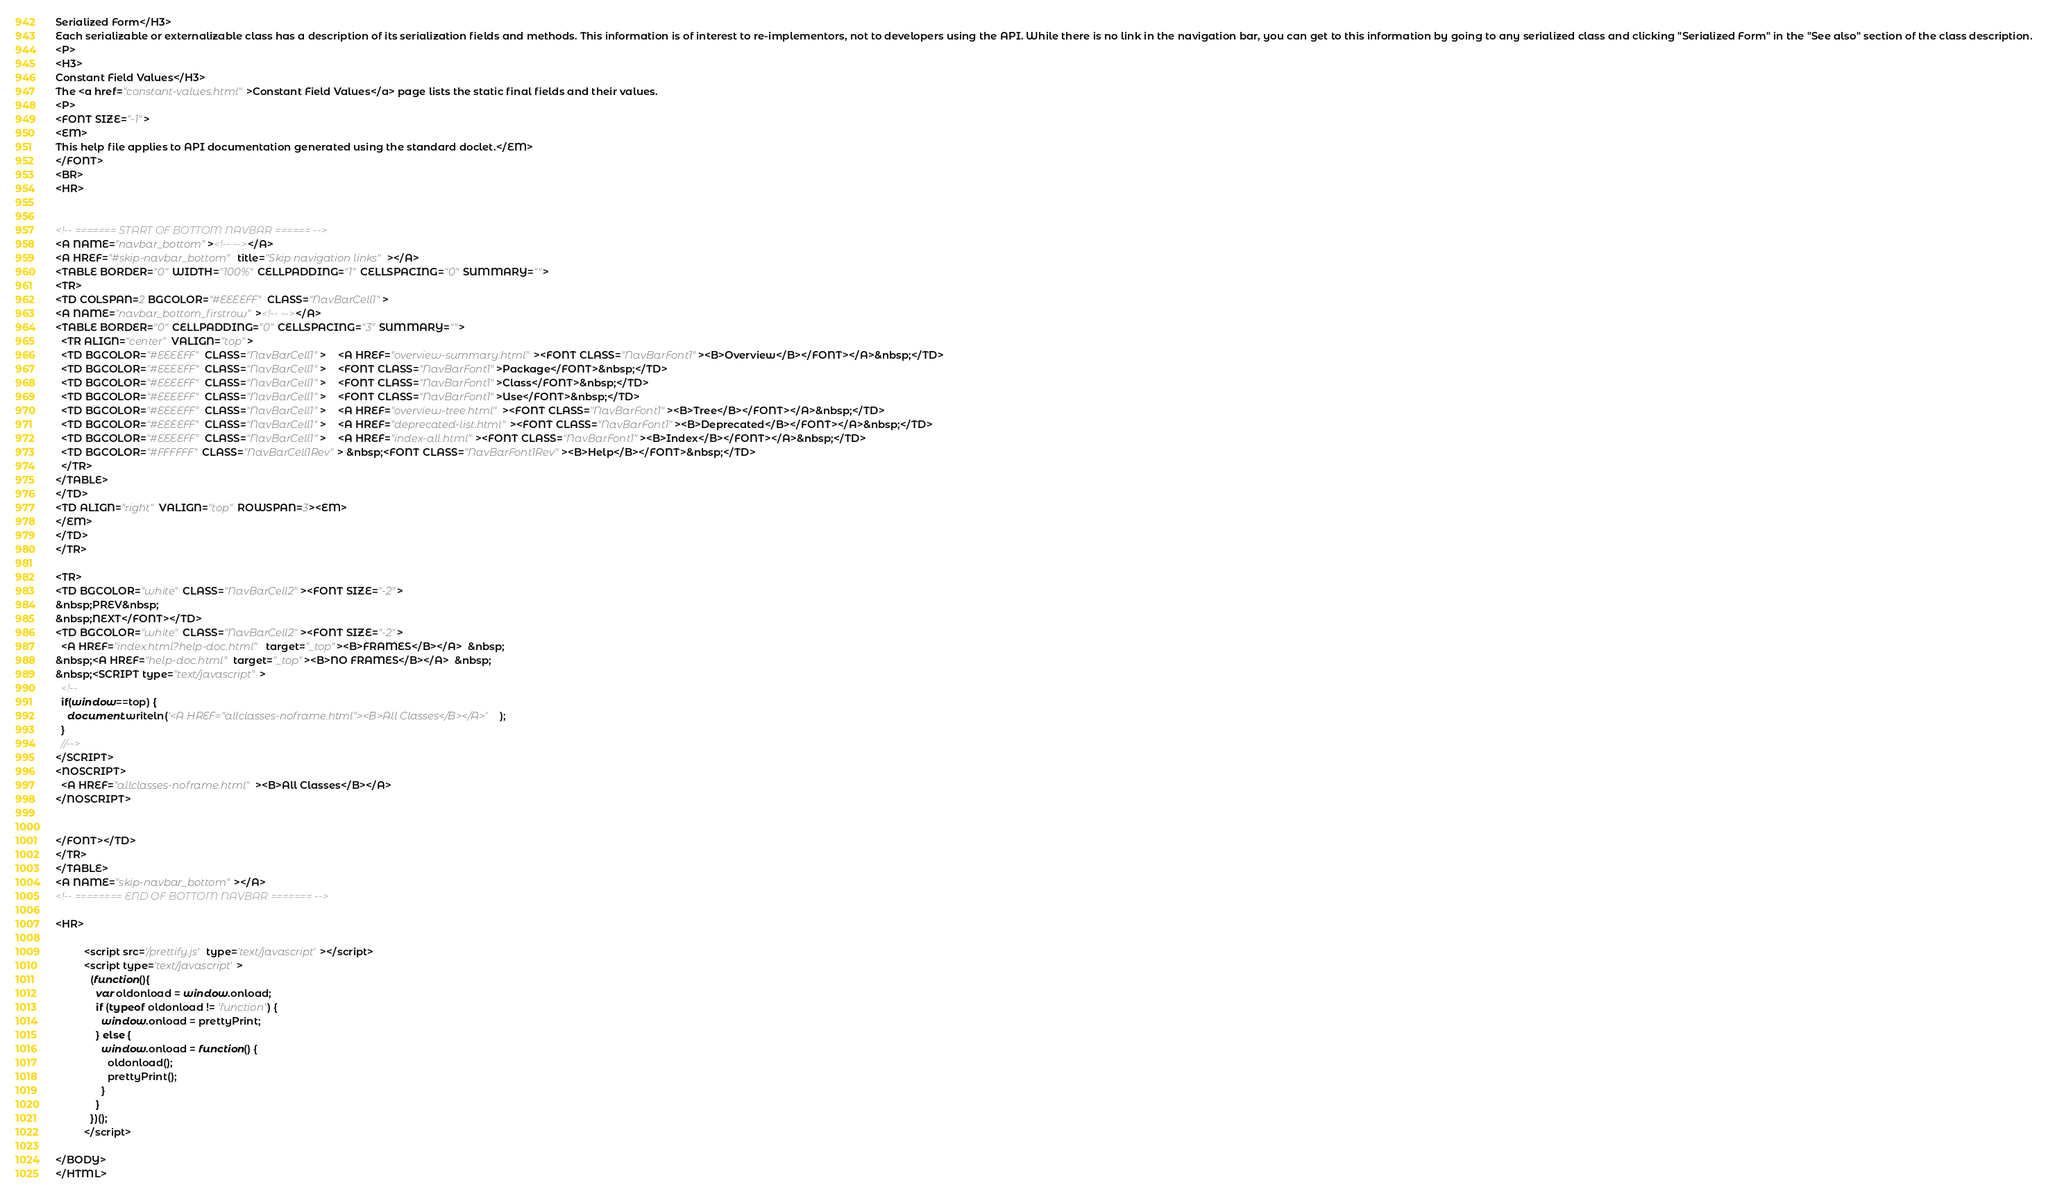<code> <loc_0><loc_0><loc_500><loc_500><_HTML_>Serialized Form</H3>
Each serializable or externalizable class has a description of its serialization fields and methods. This information is of interest to re-implementors, not to developers using the API. While there is no link in the navigation bar, you can get to this information by going to any serialized class and clicking "Serialized Form" in the "See also" section of the class description.
<P>
<H3>
Constant Field Values</H3>
The <a href="constant-values.html">Constant Field Values</a> page lists the static final fields and their values.
<P>
<FONT SIZE="-1">
<EM>
This help file applies to API documentation generated using the standard doclet.</EM>
</FONT>
<BR>
<HR>


<!-- ======= START OF BOTTOM NAVBAR ====== -->
<A NAME="navbar_bottom"><!-- --></A>
<A HREF="#skip-navbar_bottom" title="Skip navigation links"></A>
<TABLE BORDER="0" WIDTH="100%" CELLPADDING="1" CELLSPACING="0" SUMMARY="">
<TR>
<TD COLSPAN=2 BGCOLOR="#EEEEFF" CLASS="NavBarCell1">
<A NAME="navbar_bottom_firstrow"><!-- --></A>
<TABLE BORDER="0" CELLPADDING="0" CELLSPACING="3" SUMMARY="">
  <TR ALIGN="center" VALIGN="top">
  <TD BGCOLOR="#EEEEFF" CLASS="NavBarCell1">    <A HREF="overview-summary.html"><FONT CLASS="NavBarFont1"><B>Overview</B></FONT></A>&nbsp;</TD>
  <TD BGCOLOR="#EEEEFF" CLASS="NavBarCell1">    <FONT CLASS="NavBarFont1">Package</FONT>&nbsp;</TD>
  <TD BGCOLOR="#EEEEFF" CLASS="NavBarCell1">    <FONT CLASS="NavBarFont1">Class</FONT>&nbsp;</TD>
  <TD BGCOLOR="#EEEEFF" CLASS="NavBarCell1">    <FONT CLASS="NavBarFont1">Use</FONT>&nbsp;</TD>
  <TD BGCOLOR="#EEEEFF" CLASS="NavBarCell1">    <A HREF="overview-tree.html"><FONT CLASS="NavBarFont1"><B>Tree</B></FONT></A>&nbsp;</TD>
  <TD BGCOLOR="#EEEEFF" CLASS="NavBarCell1">    <A HREF="deprecated-list.html"><FONT CLASS="NavBarFont1"><B>Deprecated</B></FONT></A>&nbsp;</TD>
  <TD BGCOLOR="#EEEEFF" CLASS="NavBarCell1">    <A HREF="index-all.html"><FONT CLASS="NavBarFont1"><B>Index</B></FONT></A>&nbsp;</TD>
  <TD BGCOLOR="#FFFFFF" CLASS="NavBarCell1Rev"> &nbsp;<FONT CLASS="NavBarFont1Rev"><B>Help</B></FONT>&nbsp;</TD>
  </TR>
</TABLE>
</TD>
<TD ALIGN="right" VALIGN="top" ROWSPAN=3><EM>
</EM>
</TD>
</TR>

<TR>
<TD BGCOLOR="white" CLASS="NavBarCell2"><FONT SIZE="-2">
&nbsp;PREV&nbsp;
&nbsp;NEXT</FONT></TD>
<TD BGCOLOR="white" CLASS="NavBarCell2"><FONT SIZE="-2">
  <A HREF="index.html?help-doc.html" target="_top"><B>FRAMES</B></A>  &nbsp;
&nbsp;<A HREF="help-doc.html" target="_top"><B>NO FRAMES</B></A>  &nbsp;
&nbsp;<SCRIPT type="text/javascript">
  <!--
  if(window==top) {
    document.writeln('<A HREF="allclasses-noframe.html"><B>All Classes</B></A>');
  }
  //-->
</SCRIPT>
<NOSCRIPT>
  <A HREF="allclasses-noframe.html"><B>All Classes</B></A>
</NOSCRIPT>


</FONT></TD>
</TR>
</TABLE>
<A NAME="skip-navbar_bottom"></A>
<!-- ======== END OF BOTTOM NAVBAR ======= -->

<HR>

          <script src='/prettify.js' type='text/javascript'></script>
          <script type='text/javascript'>
            (function(){
              var oldonload = window.onload;
              if (typeof oldonload != 'function') {
                window.onload = prettyPrint;
              } else {
                window.onload = function() {
                  oldonload();
                  prettyPrint();
                }
              }
            })();
          </script>
        
</BODY>
</HTML>
</code> 